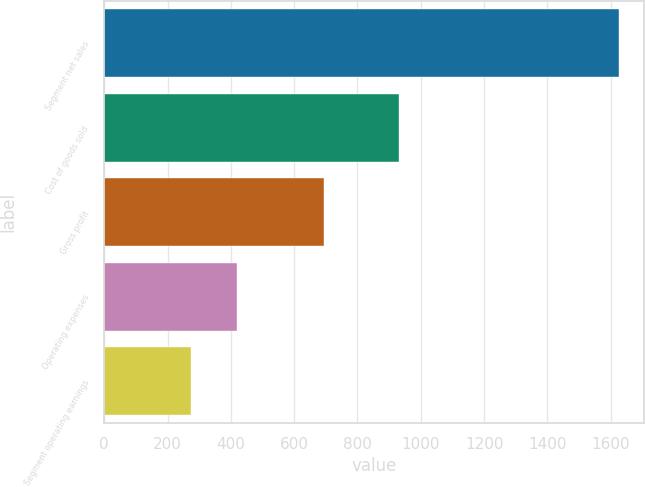<chart> <loc_0><loc_0><loc_500><loc_500><bar_chart><fcel>Segment net sales<fcel>Cost of goods sold<fcel>Gross profit<fcel>Operating expenses<fcel>Segment operating earnings<nl><fcel>1625.1<fcel>930.9<fcel>694.2<fcel>419.5<fcel>274.7<nl></chart> 